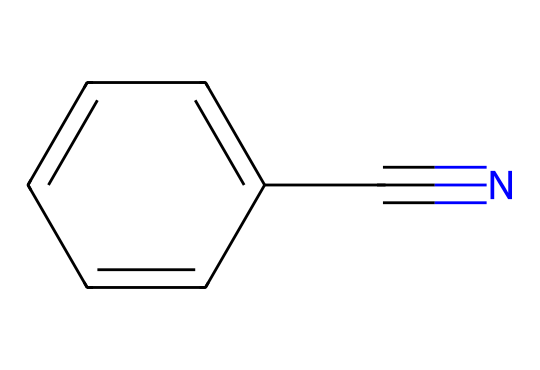how many rings are present in this structure? The SMILES representation shows a linear aromatic system without any enclosed structures, indicating there are no rings present.
Answer: zero what type of functional group is present in benzonitrile? The presence of "C#N" in the SMILES indicates a nitrile functional group, which consists of a carbon atom triple-bonded to a nitrogen atom.
Answer: nitrile how many carbon atoms are in this molecule? By analyzing the SMILES string, there are six carbon atoms in the benzene ring and one additional carbon from the nitrile group, totalling seven carbon atoms.
Answer: seven what is the hybridization of the nitrogen atom in benzonitrile? The nitrogen in the nitrile group (C#N) is involved in a triple bond with carbon, which indicates it has sp hybridization (linear geometry).
Answer: sp what does the presence of the nitrile group imply about the reactivity of benzonitrile? The nitrile group is polar and can participate in nucleophilic reactions, which informs us that the molecule is reactive toward certain chemical processes, especially in the presence of strong nucleophiles.
Answer: reactive how does the structure of benzonitrile impact its boiling point compared to non-aromatic nitriles? The aromatic benzene ring contributes to a higher boiling point due to resonance stabilization, making it significantly higher than that of non-aromatic nitriles which lack this stabilizing feature.
Answer: higher boiling point 